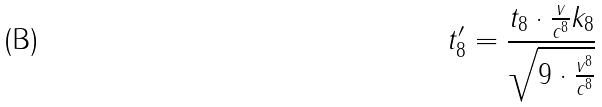Convert formula to latex. <formula><loc_0><loc_0><loc_500><loc_500>t _ { 8 } ^ { \prime } = \frac { t _ { 8 } \cdot \frac { v } { c ^ { 8 } } k _ { 8 } } { \sqrt { 9 \cdot \frac { v ^ { 8 } } { c ^ { 8 } } } }</formula> 